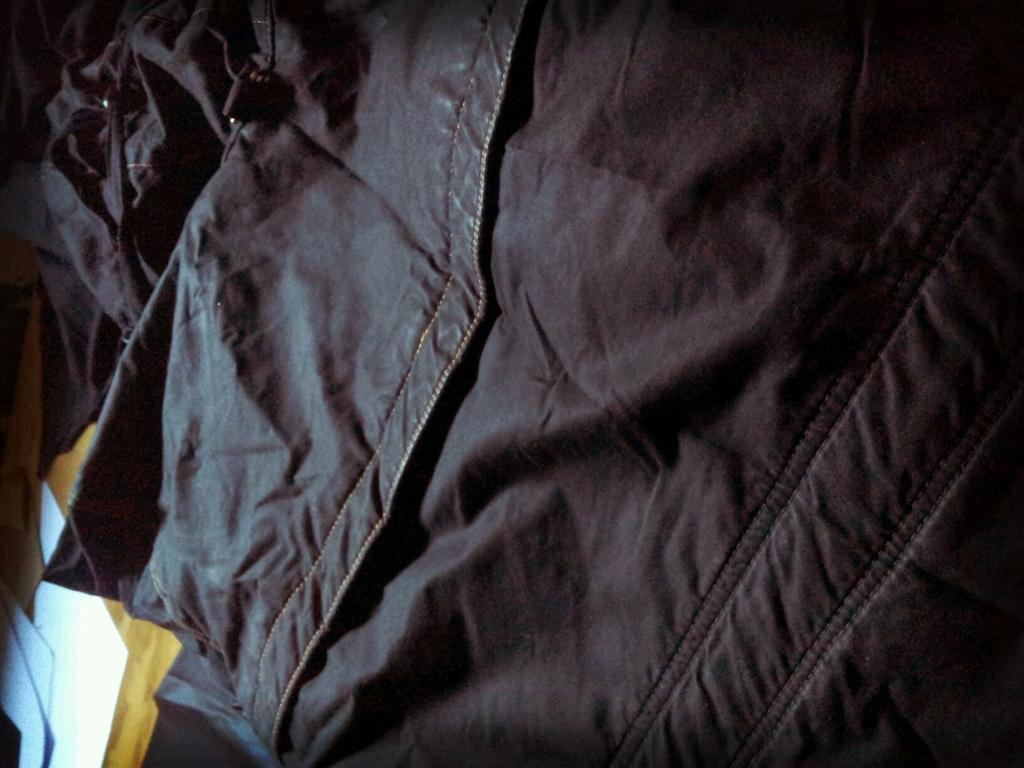What color is the cloth in the image? The cloth in the image is black. What color is the object that the black cloth is on? There is a yellow object in the image. How many white objects are on the yellow object? There are three white objects on the yellow object. What is the mass of the yellow object in the image? The mass of the yellow object cannot be determined from the image alone. How many clocks are visible in the image? There are no clocks visible in the image. 